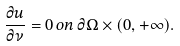<formula> <loc_0><loc_0><loc_500><loc_500>\frac { \partial u } { \partial \nu } = 0 \, o n \, \partial \Omega \times ( 0 , + \infty ) .</formula> 